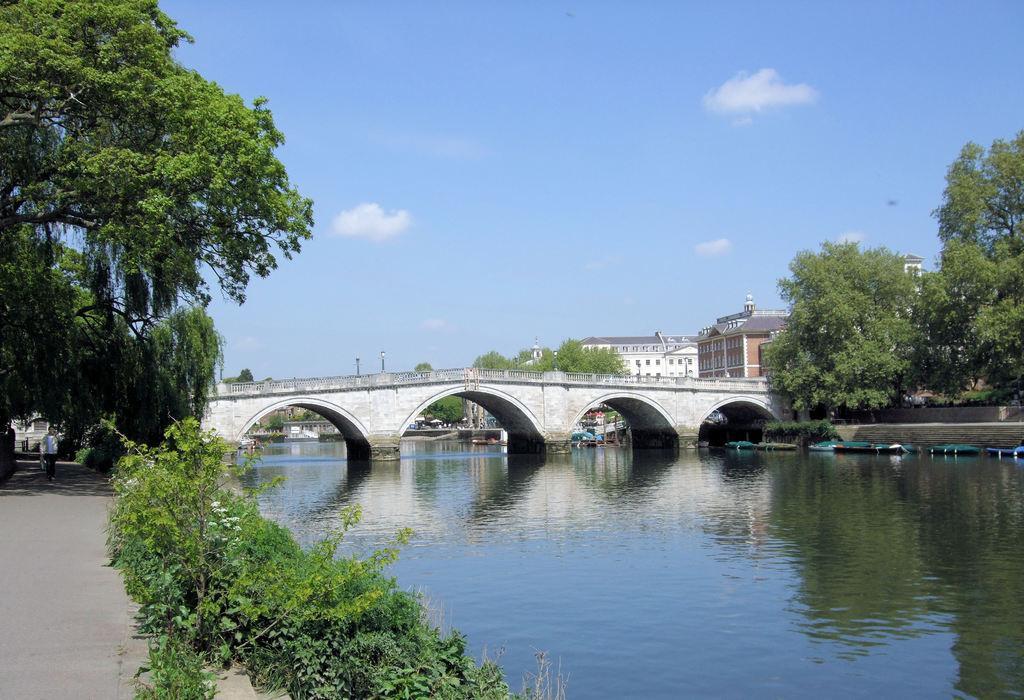How would you summarize this image in a sentence or two? In this image I can see there is a canal, also there is a bridge, trees, buildings and plants. 